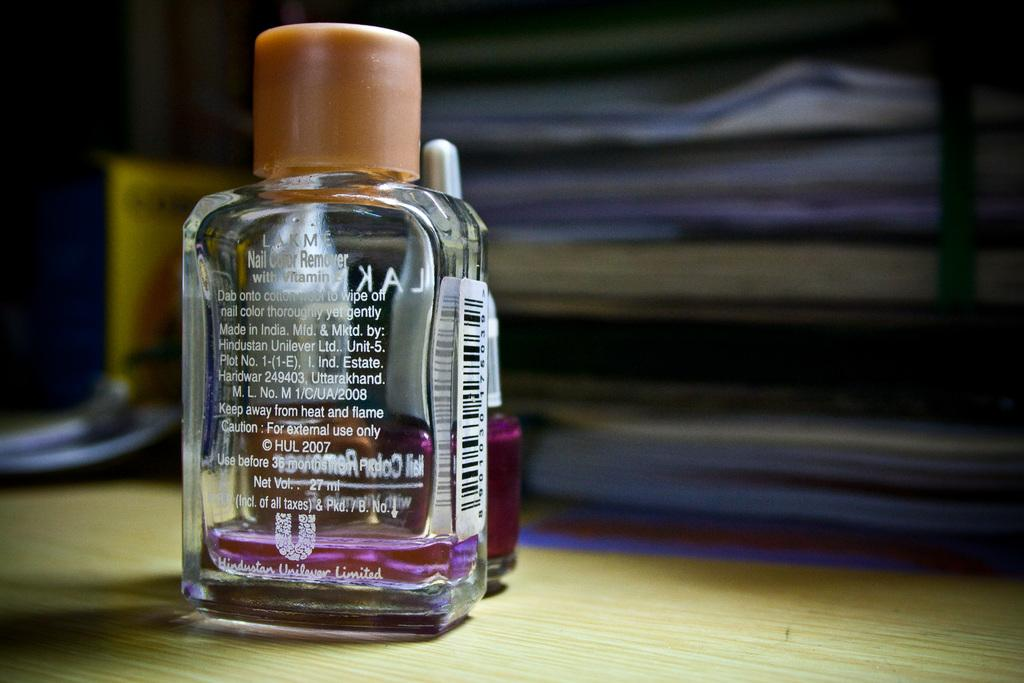<image>
Give a short and clear explanation of the subsequent image. Clear bottle of Nail Color Remover on top of a desk. 